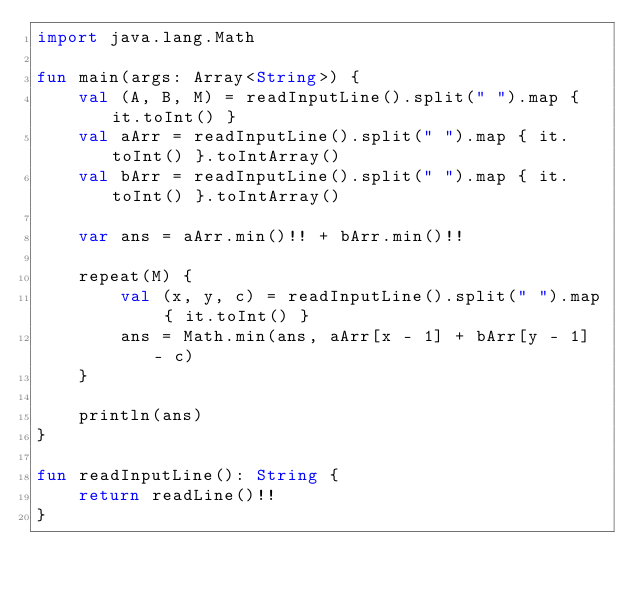<code> <loc_0><loc_0><loc_500><loc_500><_Kotlin_>import java.lang.Math

fun main(args: Array<String>) {
    val (A, B, M) = readInputLine().split(" ").map { it.toInt() }
    val aArr = readInputLine().split(" ").map { it.toInt() }.toIntArray()
    val bArr = readInputLine().split(" ").map { it.toInt() }.toIntArray()

    var ans = aArr.min()!! + bArr.min()!!

    repeat(M) {
        val (x, y, c) = readInputLine().split(" ").map { it.toInt() }
        ans = Math.min(ans, aArr[x - 1] + bArr[y - 1] - c)
    }

    println(ans)
}

fun readInputLine(): String {
    return readLine()!!
}
</code> 